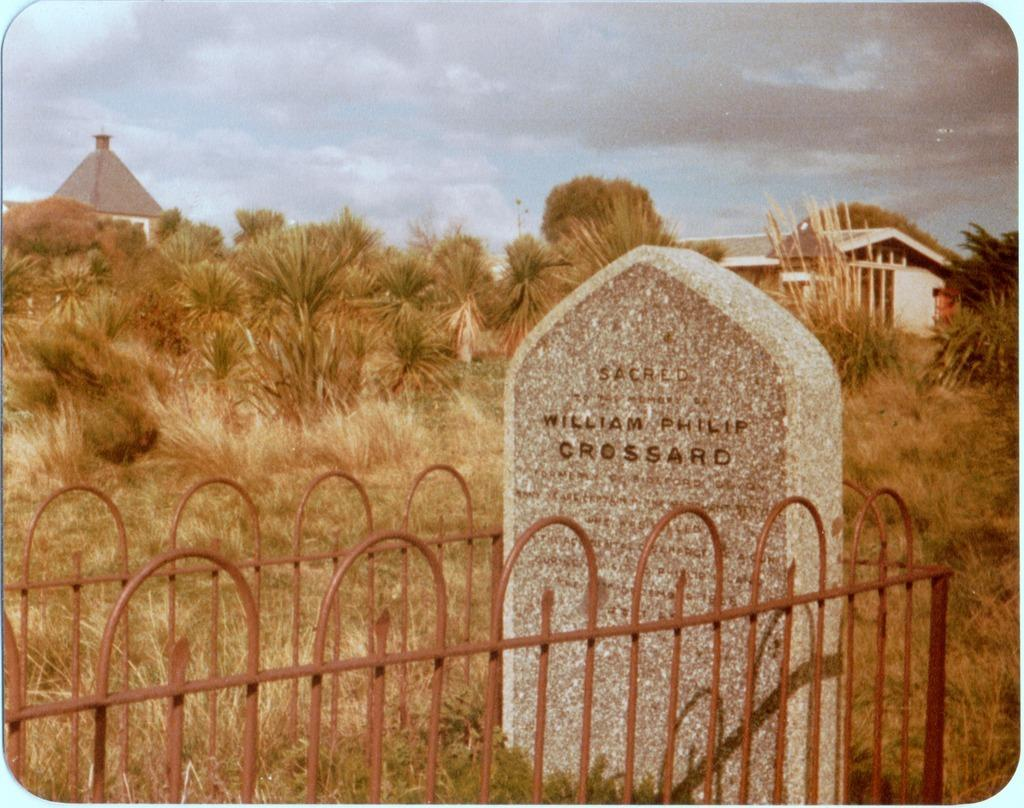What is the main subject in the center of the image? There is a stone with text in the center of the image. What can be seen near the stone? There is railing in the image. What type of natural environment is visible in the background of the image? There are trees, grass, and sky visible in the background of the image. What type of man-made structures can be seen in the background of the image? There are houses in the background of the image. What type of coal can be seen in the image? There is no coal present in the image. Is there a crowd visible in the image? There is no crowd present in the image. 